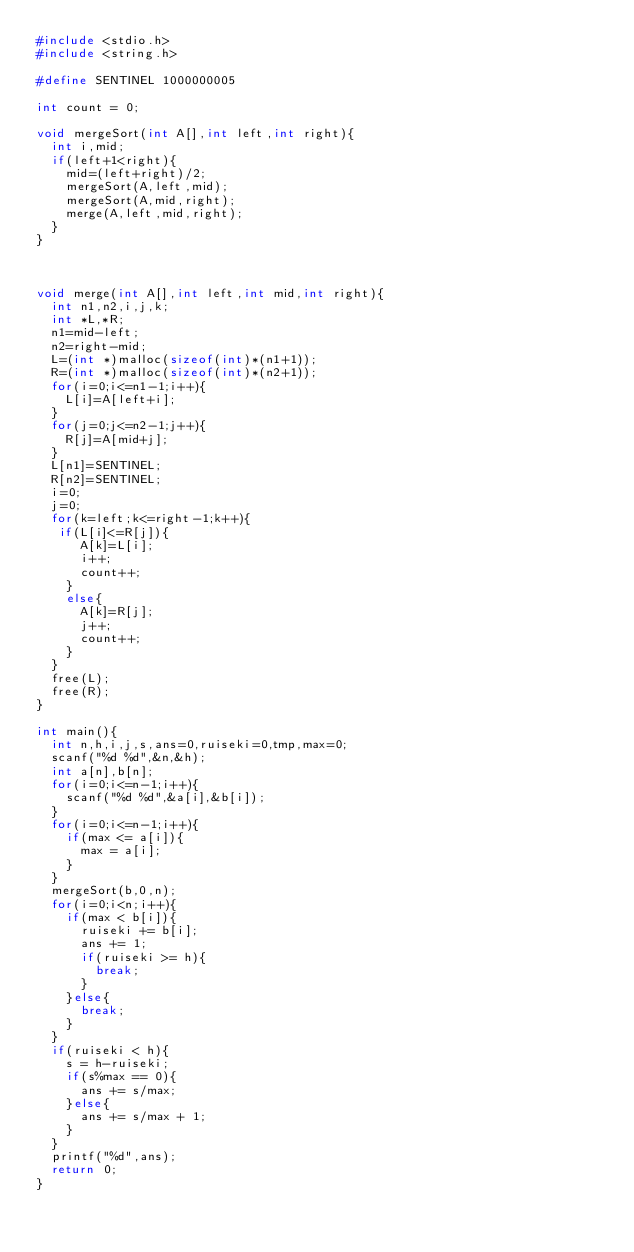<code> <loc_0><loc_0><loc_500><loc_500><_C_>#include <stdio.h>
#include <string.h>

#define SENTINEL 1000000005

int count = 0;

void mergeSort(int A[],int left,int right){
  int i,mid;
  if(left+1<right){
    mid=(left+right)/2;
    mergeSort(A,left,mid);
    mergeSort(A,mid,right);
    merge(A,left,mid,right);
  }
}



void merge(int A[],int left,int mid,int right){
  int n1,n2,i,j,k;
  int *L,*R;
  n1=mid-left;
  n2=right-mid;
  L=(int *)malloc(sizeof(int)*(n1+1));
  R=(int *)malloc(sizeof(int)*(n2+1));
  for(i=0;i<=n1-1;i++){
    L[i]=A[left+i];
  }
  for(j=0;j<=n2-1;j++){
    R[j]=A[mid+j];
  }
  L[n1]=SENTINEL;
  R[n2]=SENTINEL;
  i=0;
  j=0;
  for(k=left;k<=right-1;k++){
   if(L[i]<=R[j]){
      A[k]=L[i];
      i++;
      count++;
    }
    else{
      A[k]=R[j];
      j++;
      count++;
    }
  }
  free(L);
  free(R);
}

int main(){
  int n,h,i,j,s,ans=0,ruiseki=0,tmp,max=0;
  scanf("%d %d",&n,&h);
  int a[n],b[n];
  for(i=0;i<=n-1;i++){
    scanf("%d %d",&a[i],&b[i]);
  }
  for(i=0;i<=n-1;i++){
    if(max <= a[i]){
      max = a[i];
    }
  }
  mergeSort(b,0,n);
  for(i=0;i<n;i++){
    if(max < b[i]){
      ruiseki += b[i];
      ans += 1;
      if(ruiseki >= h){
        break;
      }
    }else{
      break;
    }
  }
  if(ruiseki < h){
    s = h-ruiseki;
    if(s%max == 0){
      ans += s/max;
    }else{
      ans += s/max + 1;
    }
  }
  printf("%d",ans);
  return 0;
}</code> 